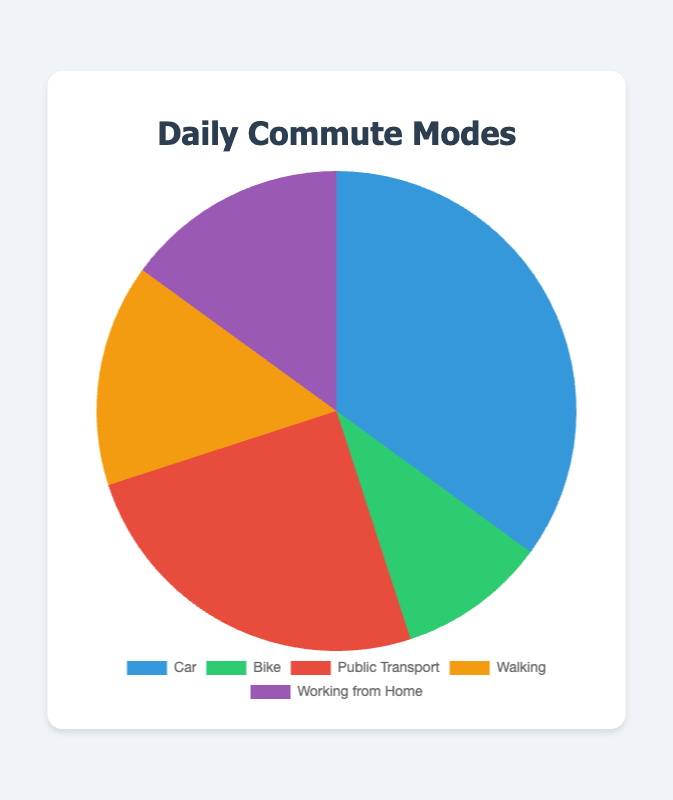Which mode of transport is used by the highest percentage of people? The pie chart shows that the "Car" segment is the largest with 35%.
Answer: Car What is the combined percentage of people who use either Public Transport or Walking? The individual percentages for Public Transport and Walking are 25% and 15% respectively. When combined, their total is 25% + 15% = 40%.
Answer: 40% How many modes of transport have the same percentage contribution? By examining the pie chart, we see that both Walking and Working from Home have the same percentage of 15%.
Answer: 2 (Walking and Working from Home) Which mode of transport has the smallest percentage, and what is that percentage? From the pie chart, Bike is the mode of transport with the smallest segment, accounting for 10%.
Answer: Bike, 10% What is the difference between the percentage of people using a Car and those using Public Transport? The percentage for Car is 35% and for Public Transport is 25%. The difference is 35% - 25% = 10%.
Answer: 10% In terms of visual appearance, which sections of the pie chart are closest in size? The sections for Walking and Working from Home are both similar in size as they both represent 15%.
Answer: Walking and Working from Home What percentage of people do not use a Car for their daily commute? To find this, subtract the percentage of people using a Car from 100%. That is 100% - 35% = 65%.
Answer: 65% Compare the sum of the percentages of people using Bike and Working from Home to those using Public Transport. Which is higher? The sum for Bike and Working from Home is 10% + 15% = 25%, which is equal to the Public Transport segment of 25%.
Answer: They are equal How much more popular is Car as a mode of transport compared to Bike in percentage terms? The percentage for Car is 35% and for Bike is 10%. The difference is 35% - 10% = 25%.
Answer: 25% What fraction of people are either working from home or walking? Summing up the percentages for Working from Home and Walking gives us 15% + 15% = 30%. As a fraction, this is 30/100, which simplifies to 3/10.
Answer: 3/10 